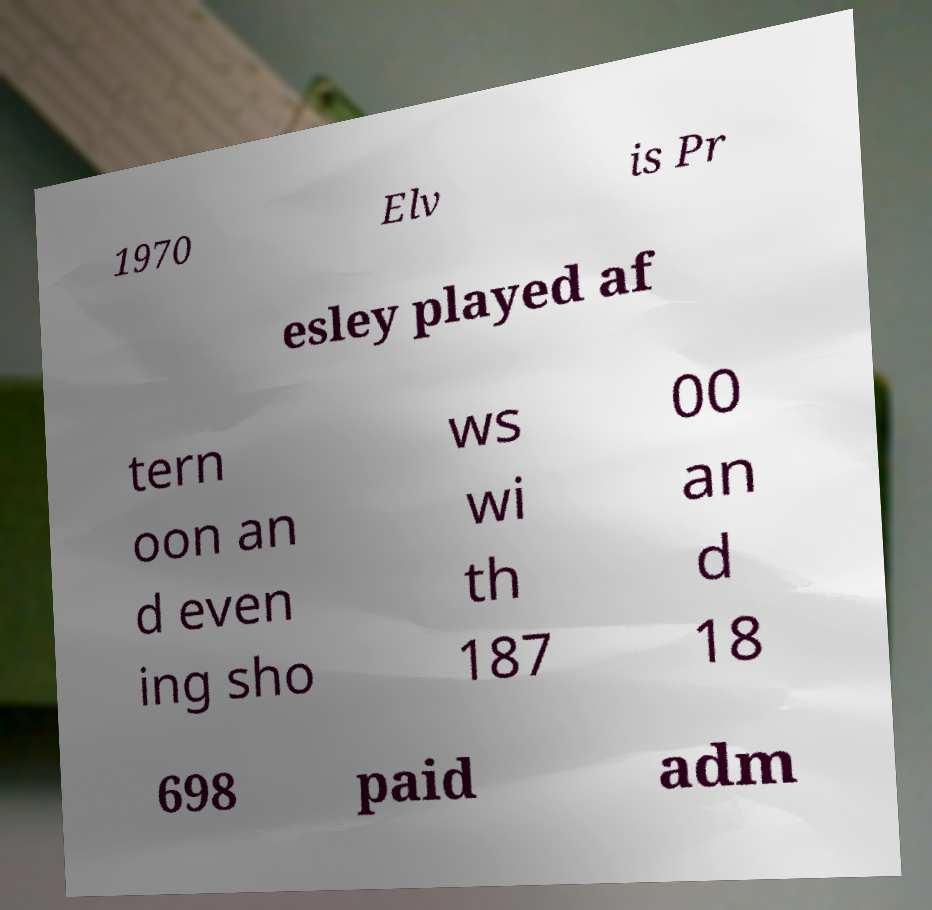What messages or text are displayed in this image? I need them in a readable, typed format. 1970 Elv is Pr esley played af tern oon an d even ing sho ws wi th 187 00 an d 18 698 paid adm 